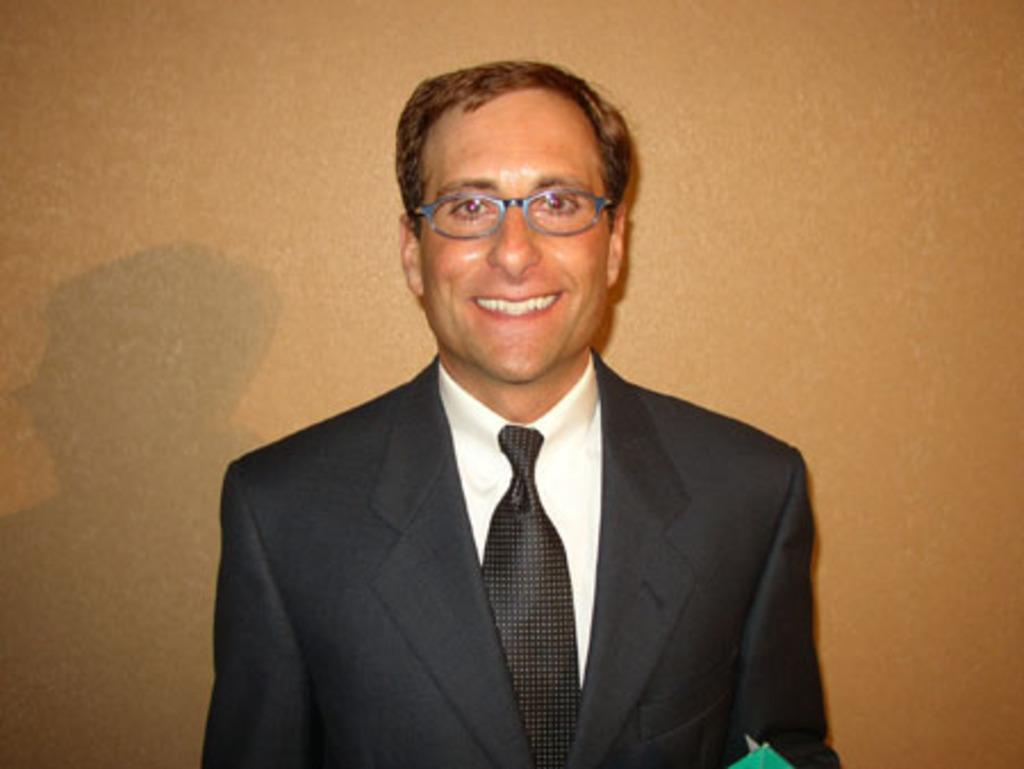What is present in the image? There is a person in the image. What type of clothing is the person wearing? The person is wearing a blazer and a tie. What accessory is the person wearing? The person is wearing spectacles. What can be seen in the background of the image? There is a wall in the background of the image. What type of skate is the person using in the image? There is no skate present in the image. How many units of the jar can be seen in the image? There is no jar present in the image. 